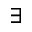<formula> <loc_0><loc_0><loc_500><loc_500>\exists</formula> 